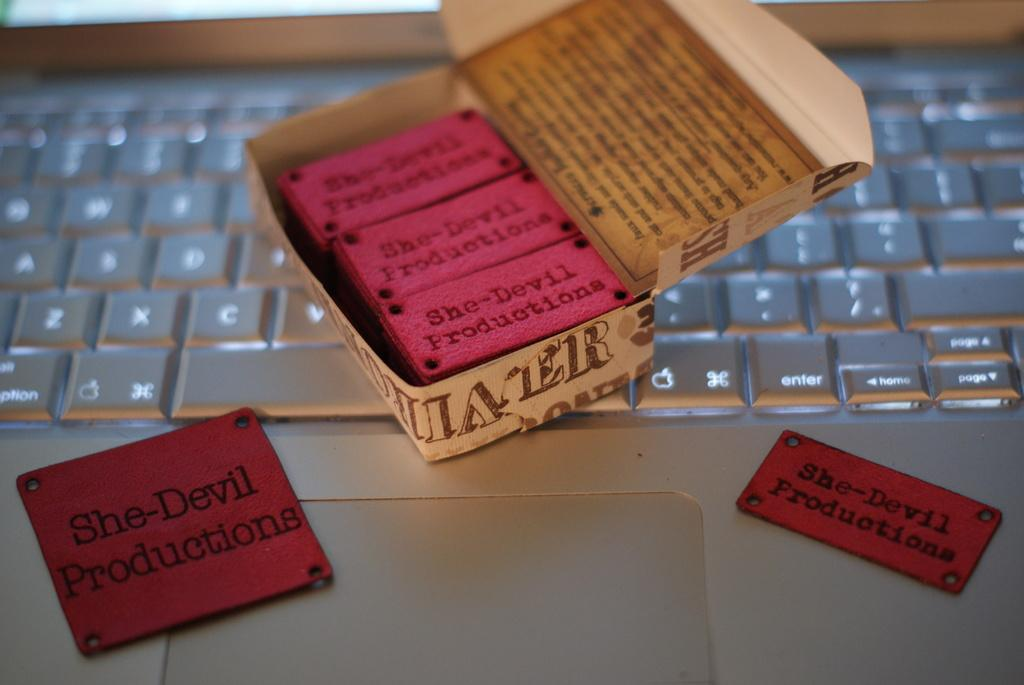<image>
Offer a succinct explanation of the picture presented. A keyboard with a box of labels that say She-Devil Productions. 